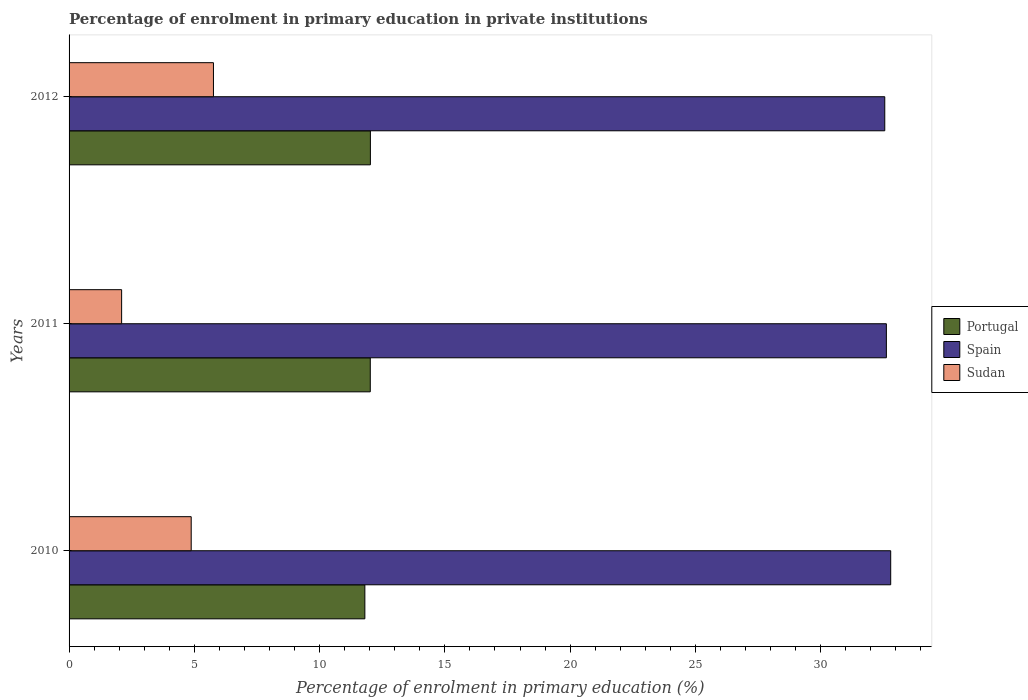How many groups of bars are there?
Ensure brevity in your answer.  3. How many bars are there on the 2nd tick from the top?
Offer a very short reply. 3. What is the label of the 3rd group of bars from the top?
Ensure brevity in your answer.  2010. In how many cases, is the number of bars for a given year not equal to the number of legend labels?
Provide a short and direct response. 0. What is the percentage of enrolment in primary education in Portugal in 2010?
Offer a terse response. 11.81. Across all years, what is the maximum percentage of enrolment in primary education in Spain?
Give a very brief answer. 32.8. Across all years, what is the minimum percentage of enrolment in primary education in Sudan?
Offer a very short reply. 2.1. In which year was the percentage of enrolment in primary education in Portugal maximum?
Provide a succinct answer. 2012. In which year was the percentage of enrolment in primary education in Spain minimum?
Offer a terse response. 2012. What is the total percentage of enrolment in primary education in Sudan in the graph?
Your response must be concise. 12.74. What is the difference between the percentage of enrolment in primary education in Sudan in 2010 and that in 2011?
Keep it short and to the point. 2.78. What is the difference between the percentage of enrolment in primary education in Spain in 2011 and the percentage of enrolment in primary education in Sudan in 2012?
Your answer should be compact. 26.86. What is the average percentage of enrolment in primary education in Portugal per year?
Provide a succinct answer. 11.95. In the year 2012, what is the difference between the percentage of enrolment in primary education in Sudan and percentage of enrolment in primary education in Spain?
Your response must be concise. -26.79. In how many years, is the percentage of enrolment in primary education in Sudan greater than 33 %?
Your response must be concise. 0. What is the ratio of the percentage of enrolment in primary education in Spain in 2010 to that in 2011?
Keep it short and to the point. 1.01. Is the percentage of enrolment in primary education in Portugal in 2010 less than that in 2012?
Keep it short and to the point. Yes. What is the difference between the highest and the second highest percentage of enrolment in primary education in Spain?
Offer a very short reply. 0.17. What is the difference between the highest and the lowest percentage of enrolment in primary education in Spain?
Ensure brevity in your answer.  0.24. Is the sum of the percentage of enrolment in primary education in Spain in 2011 and 2012 greater than the maximum percentage of enrolment in primary education in Portugal across all years?
Make the answer very short. Yes. What does the 3rd bar from the top in 2012 represents?
Ensure brevity in your answer.  Portugal. What does the 1st bar from the bottom in 2012 represents?
Provide a succinct answer. Portugal. Is it the case that in every year, the sum of the percentage of enrolment in primary education in Portugal and percentage of enrolment in primary education in Spain is greater than the percentage of enrolment in primary education in Sudan?
Give a very brief answer. Yes. How many bars are there?
Offer a very short reply. 9. Are the values on the major ticks of X-axis written in scientific E-notation?
Your answer should be compact. No. Does the graph contain grids?
Your answer should be very brief. No. What is the title of the graph?
Offer a terse response. Percentage of enrolment in primary education in private institutions. Does "South Sudan" appear as one of the legend labels in the graph?
Your response must be concise. No. What is the label or title of the X-axis?
Keep it short and to the point. Percentage of enrolment in primary education (%). What is the label or title of the Y-axis?
Provide a short and direct response. Years. What is the Percentage of enrolment in primary education (%) of Portugal in 2010?
Your answer should be very brief. 11.81. What is the Percentage of enrolment in primary education (%) of Spain in 2010?
Your answer should be compact. 32.8. What is the Percentage of enrolment in primary education (%) of Sudan in 2010?
Your response must be concise. 4.88. What is the Percentage of enrolment in primary education (%) in Portugal in 2011?
Your answer should be very brief. 12.02. What is the Percentage of enrolment in primary education (%) in Spain in 2011?
Your response must be concise. 32.62. What is the Percentage of enrolment in primary education (%) of Sudan in 2011?
Your answer should be compact. 2.1. What is the Percentage of enrolment in primary education (%) of Portugal in 2012?
Ensure brevity in your answer.  12.03. What is the Percentage of enrolment in primary education (%) of Spain in 2012?
Your answer should be very brief. 32.56. What is the Percentage of enrolment in primary education (%) in Sudan in 2012?
Your answer should be compact. 5.76. Across all years, what is the maximum Percentage of enrolment in primary education (%) in Portugal?
Your response must be concise. 12.03. Across all years, what is the maximum Percentage of enrolment in primary education (%) of Spain?
Your answer should be compact. 32.8. Across all years, what is the maximum Percentage of enrolment in primary education (%) in Sudan?
Ensure brevity in your answer.  5.76. Across all years, what is the minimum Percentage of enrolment in primary education (%) of Portugal?
Your response must be concise. 11.81. Across all years, what is the minimum Percentage of enrolment in primary education (%) in Spain?
Give a very brief answer. 32.56. Across all years, what is the minimum Percentage of enrolment in primary education (%) of Sudan?
Your answer should be compact. 2.1. What is the total Percentage of enrolment in primary education (%) of Portugal in the graph?
Keep it short and to the point. 35.86. What is the total Percentage of enrolment in primary education (%) of Spain in the graph?
Ensure brevity in your answer.  97.98. What is the total Percentage of enrolment in primary education (%) in Sudan in the graph?
Make the answer very short. 12.74. What is the difference between the Percentage of enrolment in primary education (%) in Portugal in 2010 and that in 2011?
Make the answer very short. -0.22. What is the difference between the Percentage of enrolment in primary education (%) in Spain in 2010 and that in 2011?
Keep it short and to the point. 0.17. What is the difference between the Percentage of enrolment in primary education (%) in Sudan in 2010 and that in 2011?
Provide a short and direct response. 2.78. What is the difference between the Percentage of enrolment in primary education (%) of Portugal in 2010 and that in 2012?
Provide a short and direct response. -0.22. What is the difference between the Percentage of enrolment in primary education (%) in Spain in 2010 and that in 2012?
Offer a very short reply. 0.24. What is the difference between the Percentage of enrolment in primary education (%) of Sudan in 2010 and that in 2012?
Your response must be concise. -0.89. What is the difference between the Percentage of enrolment in primary education (%) in Portugal in 2011 and that in 2012?
Provide a succinct answer. -0. What is the difference between the Percentage of enrolment in primary education (%) of Spain in 2011 and that in 2012?
Ensure brevity in your answer.  0.06. What is the difference between the Percentage of enrolment in primary education (%) of Sudan in 2011 and that in 2012?
Provide a short and direct response. -3.67. What is the difference between the Percentage of enrolment in primary education (%) in Portugal in 2010 and the Percentage of enrolment in primary education (%) in Spain in 2011?
Provide a succinct answer. -20.82. What is the difference between the Percentage of enrolment in primary education (%) in Portugal in 2010 and the Percentage of enrolment in primary education (%) in Sudan in 2011?
Provide a succinct answer. 9.71. What is the difference between the Percentage of enrolment in primary education (%) of Spain in 2010 and the Percentage of enrolment in primary education (%) of Sudan in 2011?
Offer a terse response. 30.7. What is the difference between the Percentage of enrolment in primary education (%) of Portugal in 2010 and the Percentage of enrolment in primary education (%) of Spain in 2012?
Offer a terse response. -20.75. What is the difference between the Percentage of enrolment in primary education (%) in Portugal in 2010 and the Percentage of enrolment in primary education (%) in Sudan in 2012?
Your response must be concise. 6.04. What is the difference between the Percentage of enrolment in primary education (%) in Spain in 2010 and the Percentage of enrolment in primary education (%) in Sudan in 2012?
Offer a terse response. 27.03. What is the difference between the Percentage of enrolment in primary education (%) of Portugal in 2011 and the Percentage of enrolment in primary education (%) of Spain in 2012?
Keep it short and to the point. -20.54. What is the difference between the Percentage of enrolment in primary education (%) in Portugal in 2011 and the Percentage of enrolment in primary education (%) in Sudan in 2012?
Offer a very short reply. 6.26. What is the difference between the Percentage of enrolment in primary education (%) in Spain in 2011 and the Percentage of enrolment in primary education (%) in Sudan in 2012?
Keep it short and to the point. 26.86. What is the average Percentage of enrolment in primary education (%) of Portugal per year?
Keep it short and to the point. 11.95. What is the average Percentage of enrolment in primary education (%) of Spain per year?
Make the answer very short. 32.66. What is the average Percentage of enrolment in primary education (%) of Sudan per year?
Your response must be concise. 4.25. In the year 2010, what is the difference between the Percentage of enrolment in primary education (%) in Portugal and Percentage of enrolment in primary education (%) in Spain?
Give a very brief answer. -20.99. In the year 2010, what is the difference between the Percentage of enrolment in primary education (%) of Portugal and Percentage of enrolment in primary education (%) of Sudan?
Give a very brief answer. 6.93. In the year 2010, what is the difference between the Percentage of enrolment in primary education (%) of Spain and Percentage of enrolment in primary education (%) of Sudan?
Offer a terse response. 27.92. In the year 2011, what is the difference between the Percentage of enrolment in primary education (%) of Portugal and Percentage of enrolment in primary education (%) of Spain?
Ensure brevity in your answer.  -20.6. In the year 2011, what is the difference between the Percentage of enrolment in primary education (%) of Portugal and Percentage of enrolment in primary education (%) of Sudan?
Keep it short and to the point. 9.92. In the year 2011, what is the difference between the Percentage of enrolment in primary education (%) in Spain and Percentage of enrolment in primary education (%) in Sudan?
Make the answer very short. 30.52. In the year 2012, what is the difference between the Percentage of enrolment in primary education (%) of Portugal and Percentage of enrolment in primary education (%) of Spain?
Offer a terse response. -20.53. In the year 2012, what is the difference between the Percentage of enrolment in primary education (%) in Portugal and Percentage of enrolment in primary education (%) in Sudan?
Make the answer very short. 6.26. In the year 2012, what is the difference between the Percentage of enrolment in primary education (%) in Spain and Percentage of enrolment in primary education (%) in Sudan?
Keep it short and to the point. 26.79. What is the ratio of the Percentage of enrolment in primary education (%) in Portugal in 2010 to that in 2011?
Provide a short and direct response. 0.98. What is the ratio of the Percentage of enrolment in primary education (%) of Spain in 2010 to that in 2011?
Your response must be concise. 1.01. What is the ratio of the Percentage of enrolment in primary education (%) of Sudan in 2010 to that in 2011?
Give a very brief answer. 2.32. What is the ratio of the Percentage of enrolment in primary education (%) of Portugal in 2010 to that in 2012?
Offer a very short reply. 0.98. What is the ratio of the Percentage of enrolment in primary education (%) of Spain in 2010 to that in 2012?
Provide a succinct answer. 1.01. What is the ratio of the Percentage of enrolment in primary education (%) of Sudan in 2010 to that in 2012?
Offer a terse response. 0.85. What is the ratio of the Percentage of enrolment in primary education (%) of Spain in 2011 to that in 2012?
Your answer should be compact. 1. What is the ratio of the Percentage of enrolment in primary education (%) of Sudan in 2011 to that in 2012?
Ensure brevity in your answer.  0.36. What is the difference between the highest and the second highest Percentage of enrolment in primary education (%) in Portugal?
Keep it short and to the point. 0. What is the difference between the highest and the second highest Percentage of enrolment in primary education (%) of Spain?
Give a very brief answer. 0.17. What is the difference between the highest and the second highest Percentage of enrolment in primary education (%) of Sudan?
Provide a short and direct response. 0.89. What is the difference between the highest and the lowest Percentage of enrolment in primary education (%) of Portugal?
Provide a short and direct response. 0.22. What is the difference between the highest and the lowest Percentage of enrolment in primary education (%) of Spain?
Provide a short and direct response. 0.24. What is the difference between the highest and the lowest Percentage of enrolment in primary education (%) in Sudan?
Provide a short and direct response. 3.67. 